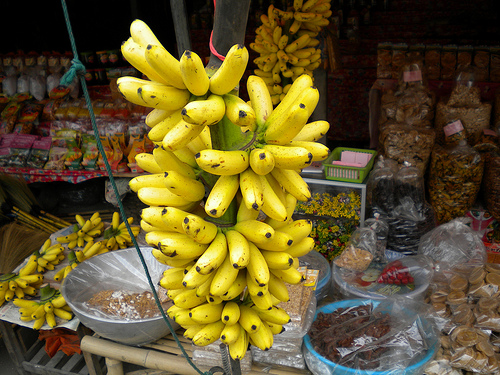Can you provide the name of another fruit visible in the image besides bananas? Yes, aside from bananas, there appears to be a variety of citrus fruits displayed in the upper part of the image. 